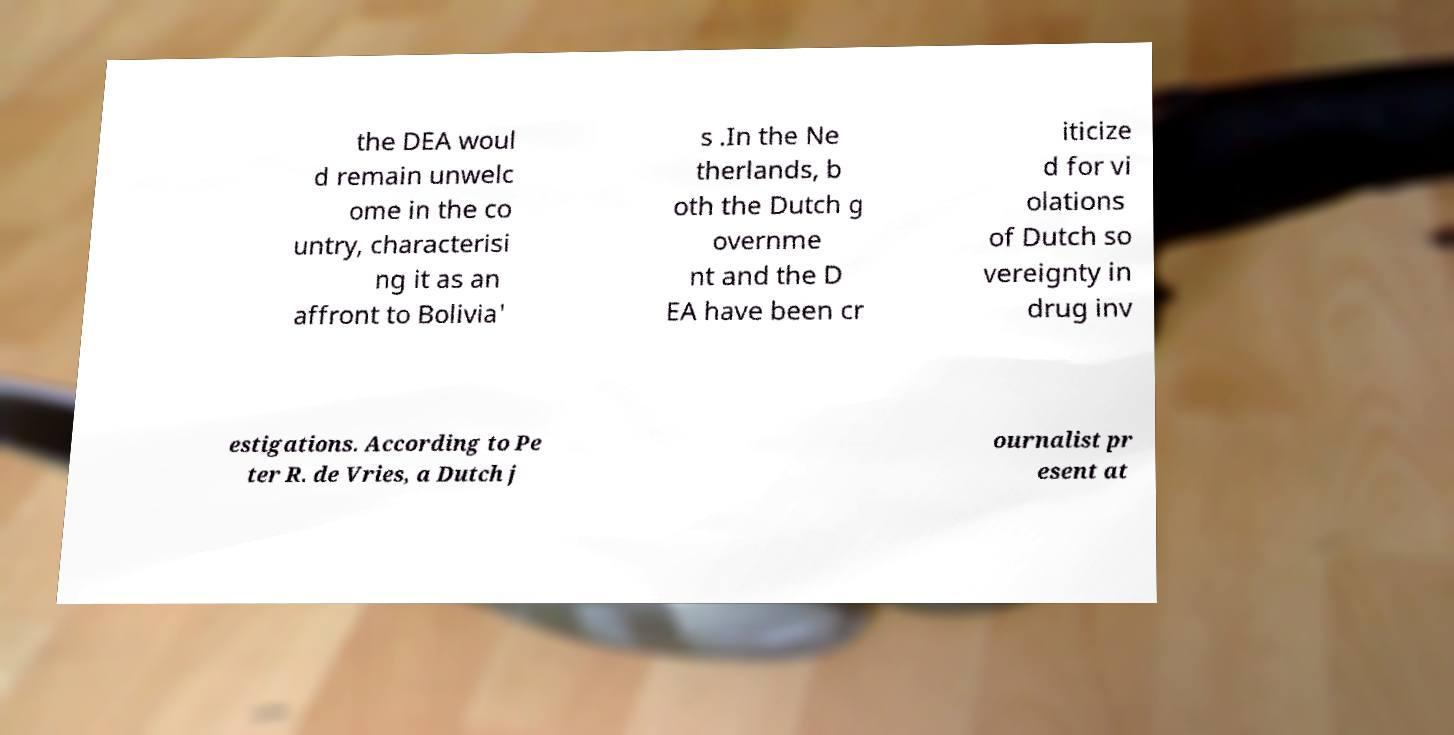I need the written content from this picture converted into text. Can you do that? the DEA woul d remain unwelc ome in the co untry, characterisi ng it as an affront to Bolivia' s .In the Ne therlands, b oth the Dutch g overnme nt and the D EA have been cr iticize d for vi olations of Dutch so vereignty in drug inv estigations. According to Pe ter R. de Vries, a Dutch j ournalist pr esent at 